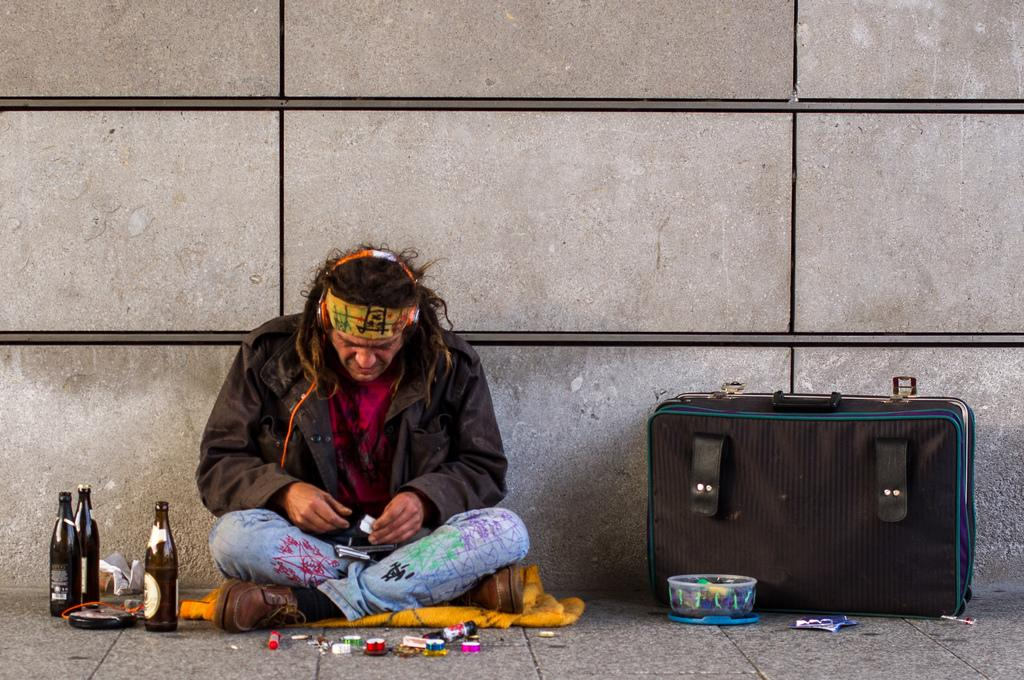What is the man in the image doing? The man is sitting on the floor in the image. What is covering the man or the floor in the image? There is a blanket in the image. What items can be seen that might be used for drinking? There are bottles in the image. What items can be seen that might be used for writing or drawing? There are papers and a marker in the image. What items can be seen that might be used for organizing or decorating? There are color tapes in the image. What items can be seen that might be used for carrying belongings? There is a luggage suitcase in the image. What items can be seen that might be used for storing items? There is a box in the image. How many fish are swimming in the box in the image? There are no fish present in the image, and the box is not depicted as containing water. 